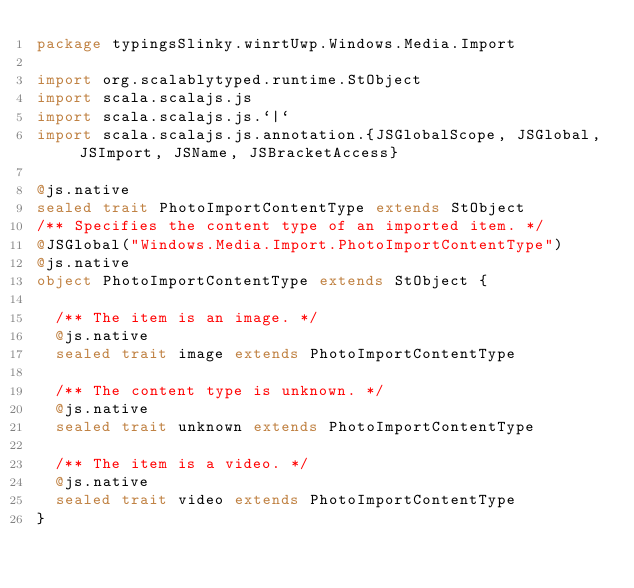<code> <loc_0><loc_0><loc_500><loc_500><_Scala_>package typingsSlinky.winrtUwp.Windows.Media.Import

import org.scalablytyped.runtime.StObject
import scala.scalajs.js
import scala.scalajs.js.`|`
import scala.scalajs.js.annotation.{JSGlobalScope, JSGlobal, JSImport, JSName, JSBracketAccess}

@js.native
sealed trait PhotoImportContentType extends StObject
/** Specifies the content type of an imported item. */
@JSGlobal("Windows.Media.Import.PhotoImportContentType")
@js.native
object PhotoImportContentType extends StObject {
  
  /** The item is an image. */
  @js.native
  sealed trait image extends PhotoImportContentType
  
  /** The content type is unknown. */
  @js.native
  sealed trait unknown extends PhotoImportContentType
  
  /** The item is a video. */
  @js.native
  sealed trait video extends PhotoImportContentType
}
</code> 